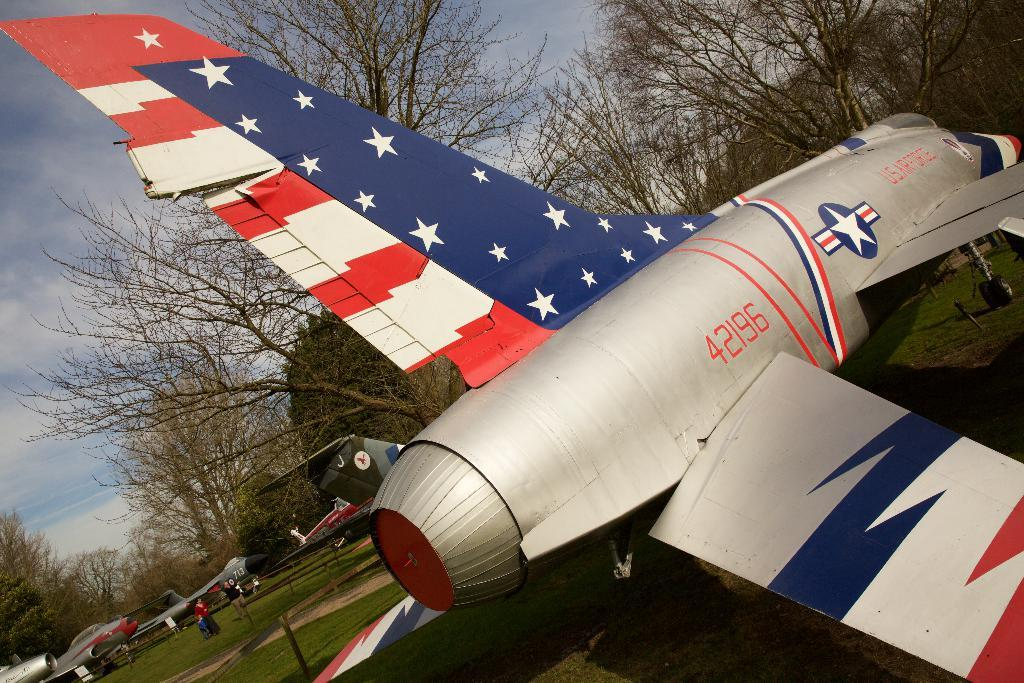<image>
Describe the image concisely. An old jet with the tail number 42196 has the American flag painted on it. 